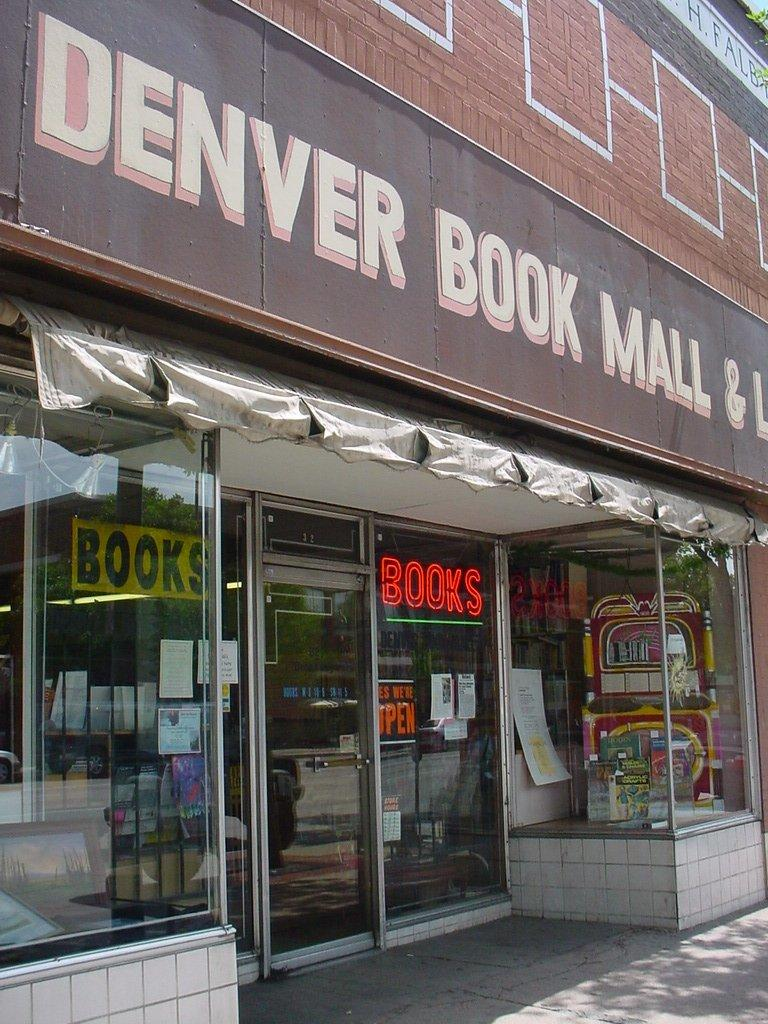Provide a one-sentence caption for the provided image. The book store in Denver is currently open. 